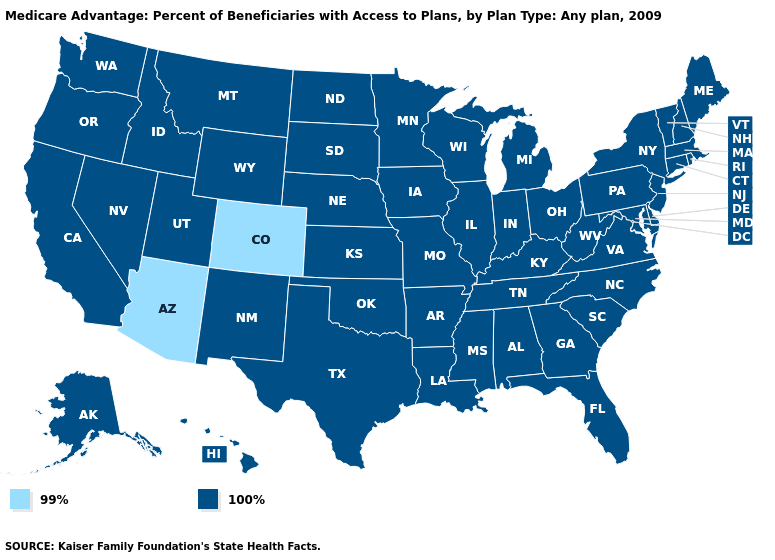What is the value of Wyoming?
Concise answer only. 100%. Does Oregon have the lowest value in the USA?
Be succinct. No. What is the lowest value in the MidWest?
Be succinct. 100%. Does the first symbol in the legend represent the smallest category?
Answer briefly. Yes. What is the value of Oregon?
Short answer required. 100%. Name the states that have a value in the range 100%?
Give a very brief answer. Alaska, Alabama, Arkansas, California, Connecticut, Delaware, Florida, Georgia, Hawaii, Iowa, Idaho, Illinois, Indiana, Kansas, Kentucky, Louisiana, Massachusetts, Maryland, Maine, Michigan, Minnesota, Missouri, Mississippi, Montana, North Carolina, North Dakota, Nebraska, New Hampshire, New Jersey, New Mexico, Nevada, New York, Ohio, Oklahoma, Oregon, Pennsylvania, Rhode Island, South Carolina, South Dakota, Tennessee, Texas, Utah, Virginia, Vermont, Washington, Wisconsin, West Virginia, Wyoming. Which states have the highest value in the USA?
Short answer required. Alaska, Alabama, Arkansas, California, Connecticut, Delaware, Florida, Georgia, Hawaii, Iowa, Idaho, Illinois, Indiana, Kansas, Kentucky, Louisiana, Massachusetts, Maryland, Maine, Michigan, Minnesota, Missouri, Mississippi, Montana, North Carolina, North Dakota, Nebraska, New Hampshire, New Jersey, New Mexico, Nevada, New York, Ohio, Oklahoma, Oregon, Pennsylvania, Rhode Island, South Carolina, South Dakota, Tennessee, Texas, Utah, Virginia, Vermont, Washington, Wisconsin, West Virginia, Wyoming. What is the value of Alabama?
Answer briefly. 100%. Among the states that border Nevada , does Arizona have the lowest value?
Quick response, please. Yes. Name the states that have a value in the range 99%?
Give a very brief answer. Arizona, Colorado. What is the value of New Mexico?
Short answer required. 100%. What is the value of Idaho?
Give a very brief answer. 100%. What is the value of Michigan?
Concise answer only. 100%. Name the states that have a value in the range 100%?
Concise answer only. Alaska, Alabama, Arkansas, California, Connecticut, Delaware, Florida, Georgia, Hawaii, Iowa, Idaho, Illinois, Indiana, Kansas, Kentucky, Louisiana, Massachusetts, Maryland, Maine, Michigan, Minnesota, Missouri, Mississippi, Montana, North Carolina, North Dakota, Nebraska, New Hampshire, New Jersey, New Mexico, Nevada, New York, Ohio, Oklahoma, Oregon, Pennsylvania, Rhode Island, South Carolina, South Dakota, Tennessee, Texas, Utah, Virginia, Vermont, Washington, Wisconsin, West Virginia, Wyoming. 